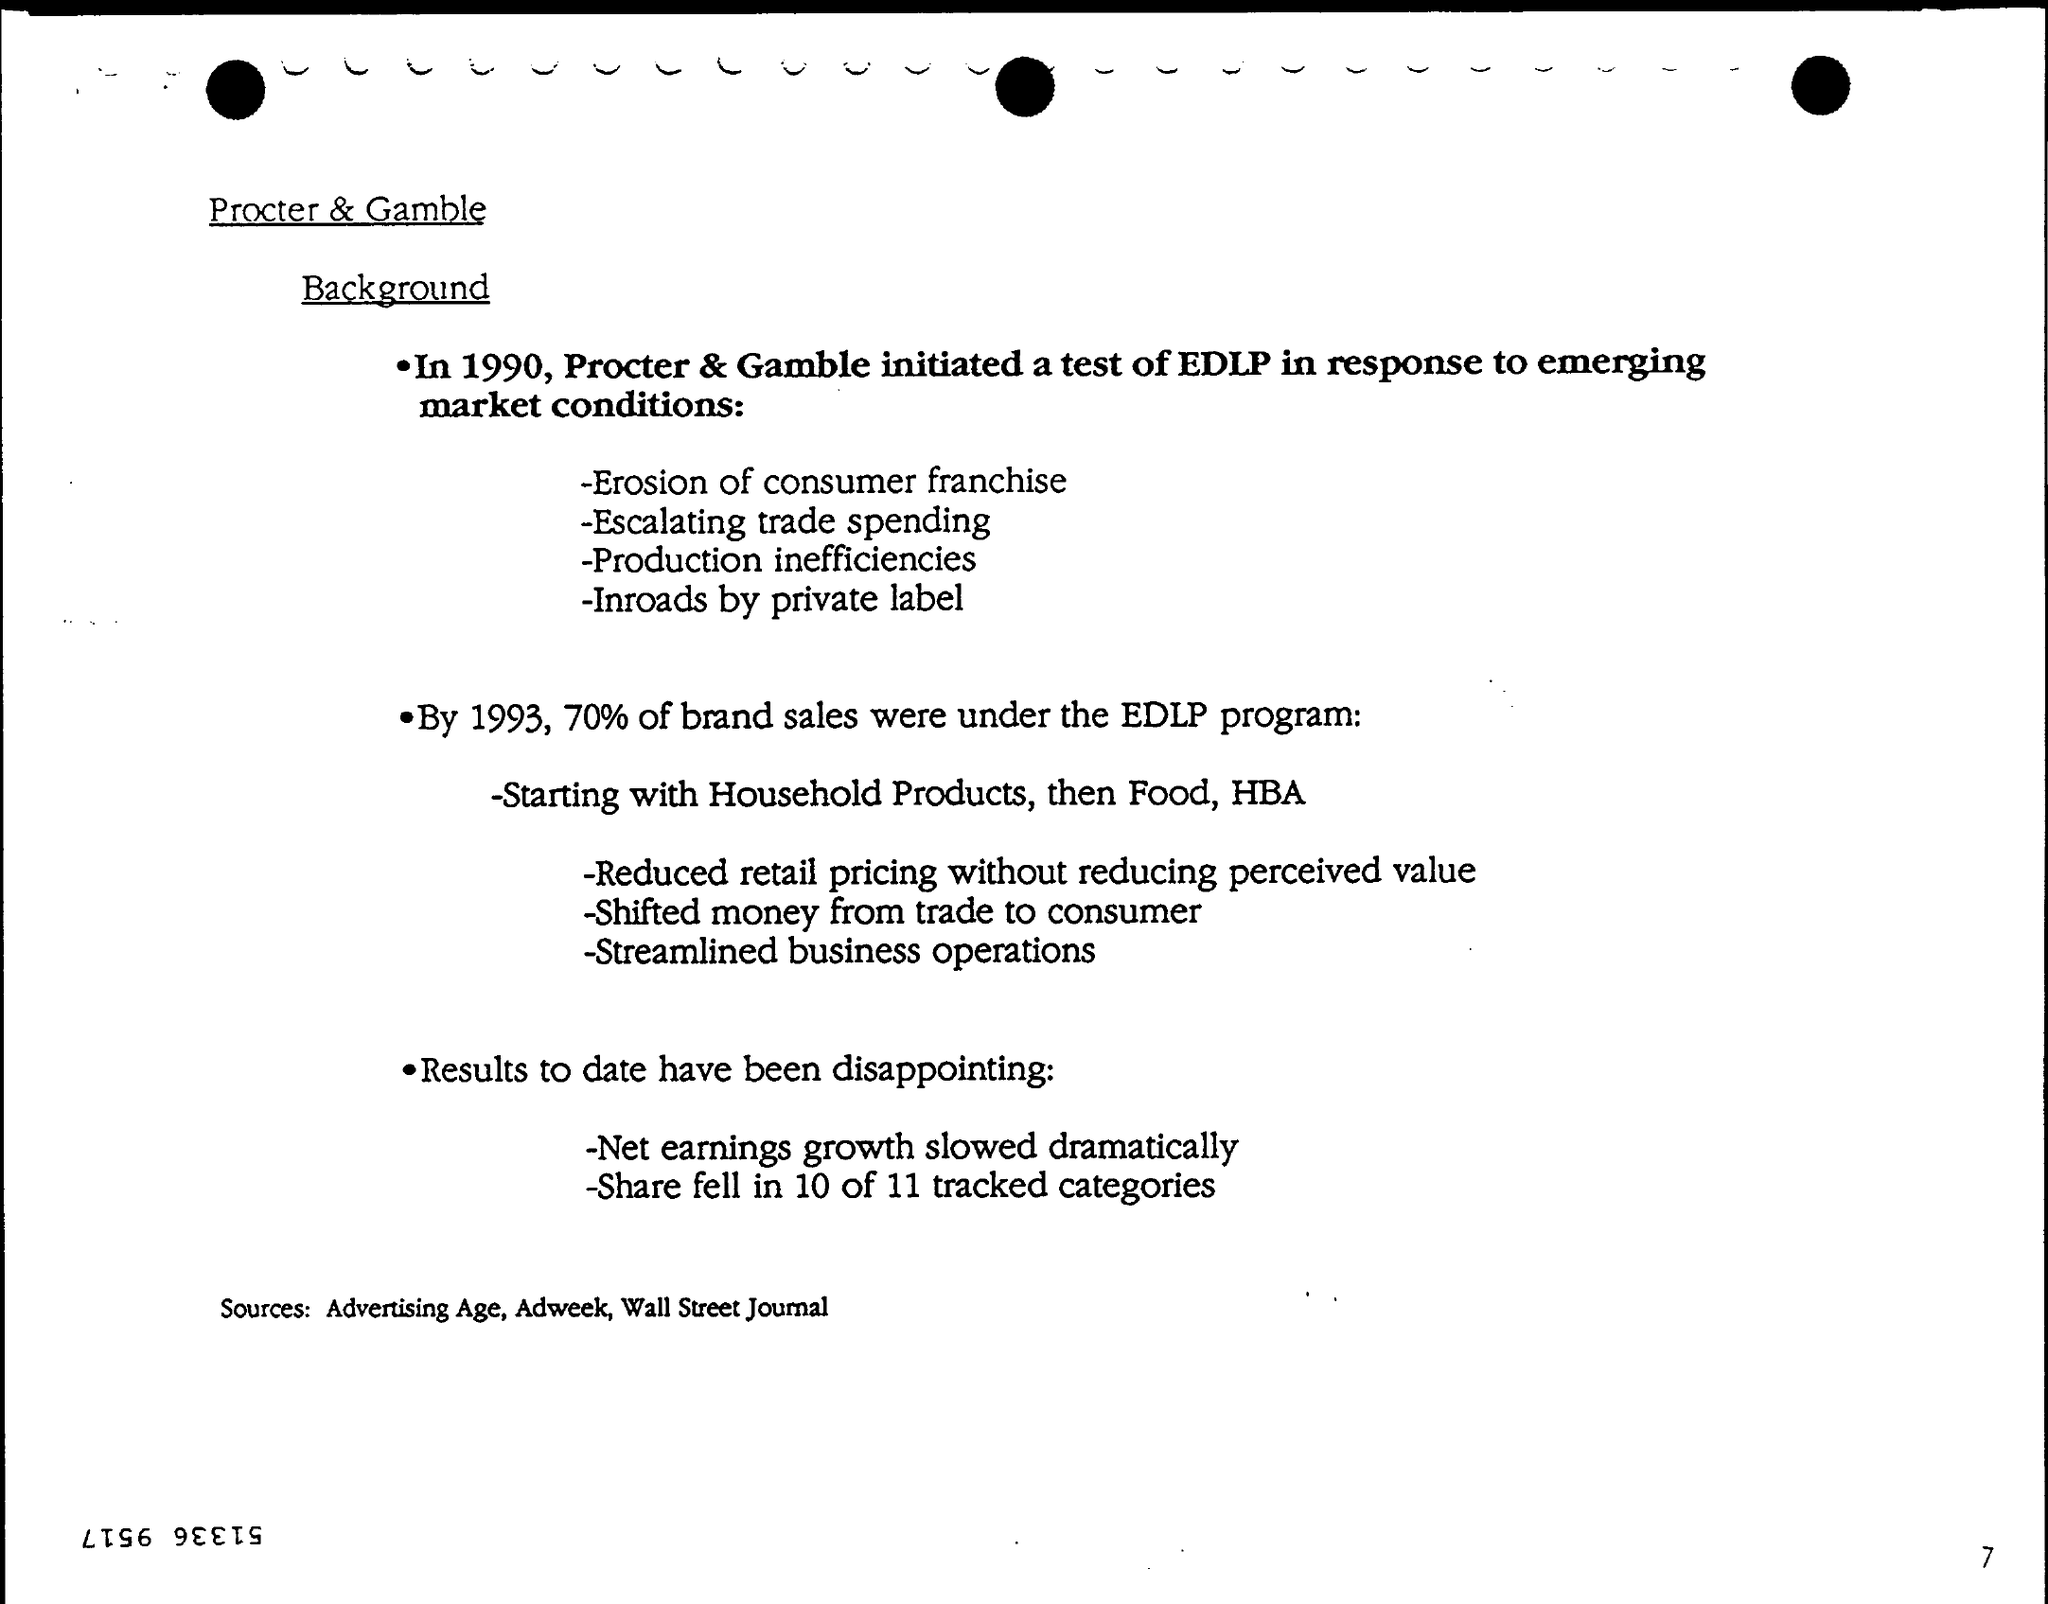What is the first title in the document?
Offer a terse response. Procter & Gamble. What is the second title in the document?
Your answer should be very brief. Background. What is the Page Number?
Make the answer very short. 7. 